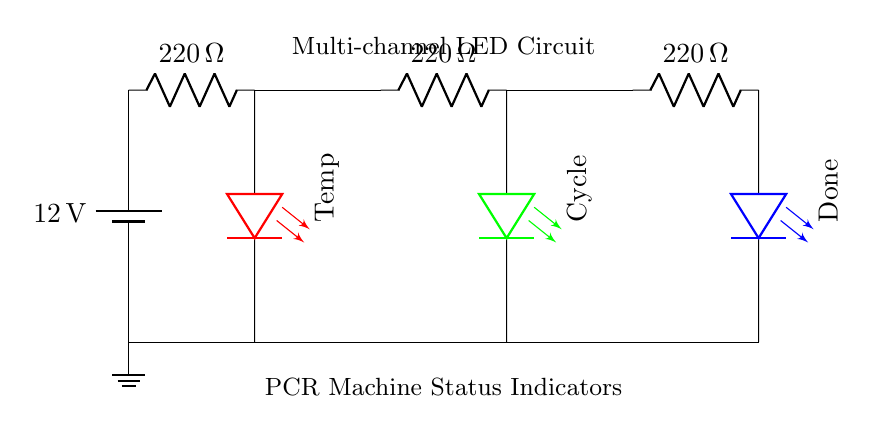What is the supply voltage of the circuit? The circuit has a battery supply labeled as 12 volts. This indicates the potential difference provided to the circuit components from the battery.
Answer: 12 volts What color is the LED for the 'Done' status? The LED for the 'Done' status is colored blue, as indicated by the label on the LED in the circuit diagram.
Answer: Blue How many resistors are present in the circuit? There are three resistors present in the circuit, each labeled with a resistance of 220 ohms. Counting each resistor shows that they are in series with the respective LED.
Answer: Three What is the resistance value of each resistor? Each resistor in the circuit has a resistance value of 220 ohms, which is specified directly next to each resistor in the diagram.
Answer: 220 ohms Which LED indicates the 'Temperature' status? The 'Temperature' status is indicated by a red LED, as shown in the diagram where the label appears next to the LED.
Answer: Red What do the resistors in the circuit do? The resistors are used to limit the current flowing through the LEDs, preventing them from burning out by ensuring they operate within safe current levels.
Answer: Limit current In which direction is the 'Cycle' LED oriented? The 'Cycle' LED is oriented vertically downward, as indicated by the orientation of the label and LED in the circuit diagram.
Answer: Downward 